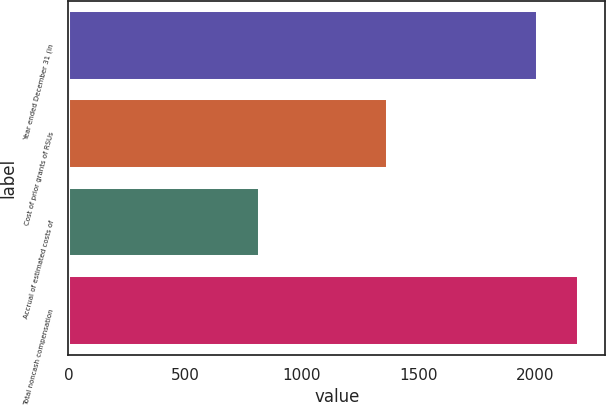<chart> <loc_0><loc_0><loc_500><loc_500><bar_chart><fcel>Year ended December 31 (in<fcel>Cost of prior grants of RSUs<fcel>Accrual of estimated costs of<fcel>Total noncash compensation<nl><fcel>2014<fcel>1371<fcel>819<fcel>2190<nl></chart> 